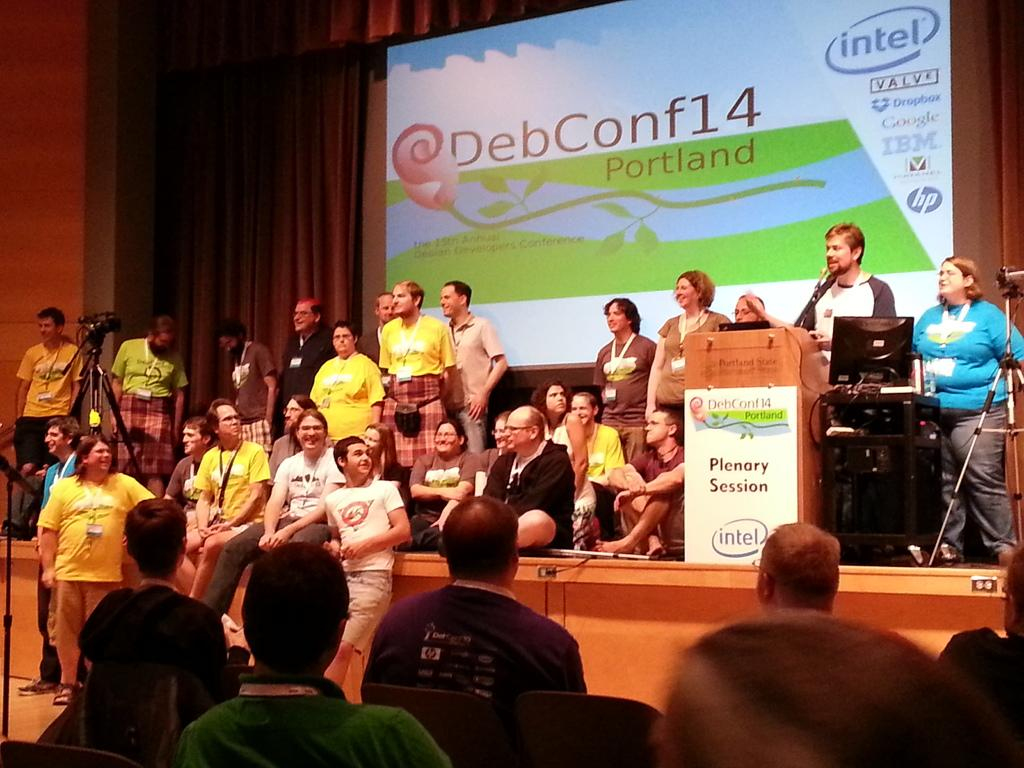What type of structure can be seen in the image? There is a wall in the image. What type of window treatment is present in the image? There are curtains in the image. What type of display device is visible in the image? There is a screen in the image. How many people are present in the image? There are people present in the image. What type of electronic device can be seen in the image? There is a laptop in the image. What type of equipment is used for capturing images in the image? There is a camera in the image. What type of breakfast is being served in the image? There is no breakfast present in the image. What type of shop can be seen in the image? There is no shop present in the image. What part of the brain is visible in the image? There is no brain present in the image. 